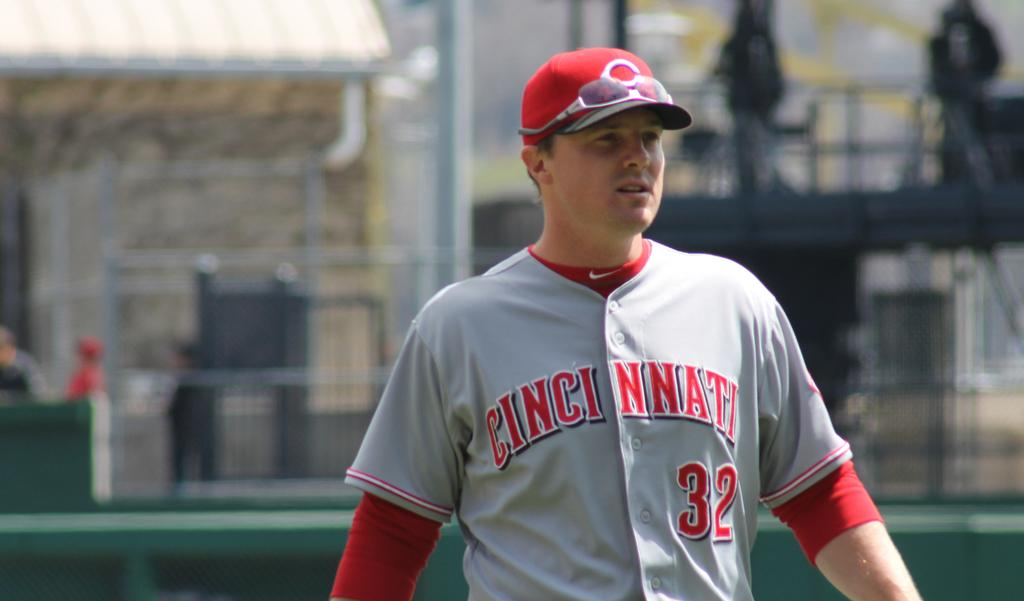Provide a one-sentence caption for the provided image. a jersey that has the city of Cincinnati on it. 